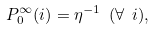<formula> <loc_0><loc_0><loc_500><loc_500>P _ { 0 } ^ { \infty } ( i ) = \eta ^ { - 1 } \ ( \forall \ i ) ,</formula> 